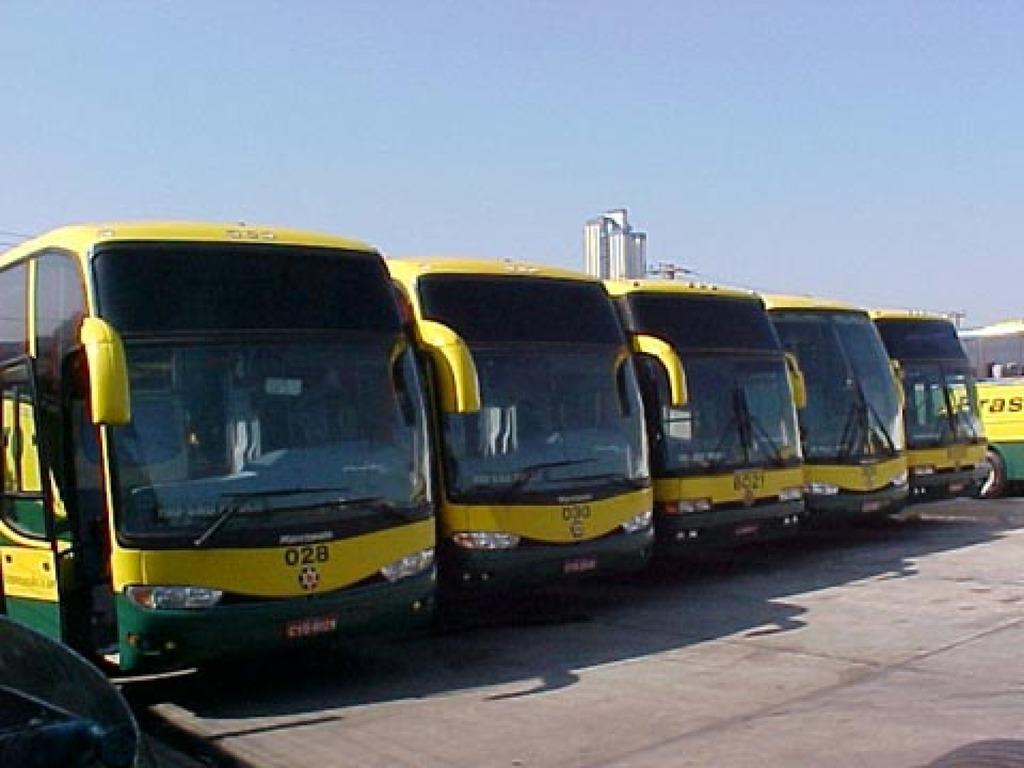What is located at the bottom of the image? There is a road at the bottom of the image. What can be seen in the foreground of the image? There are vehicles in the foreground of the image. What is visible at the top of the image? There is a sky visible at the top of the image. Can you tell me how many stamps are on the road in the image? There are no stamps present in the image; it features a road and vehicles. What type of curve is visible in the image? There is no curve visible in the image; it features a road and vehicles. 